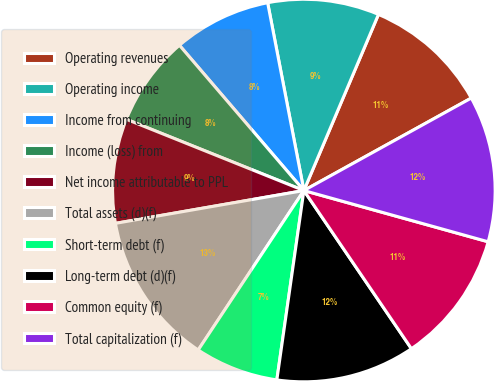Convert chart. <chart><loc_0><loc_0><loc_500><loc_500><pie_chart><fcel>Operating revenues<fcel>Operating income<fcel>Income from continuing<fcel>Income (loss) from<fcel>Net income attributable to PPL<fcel>Total assets (d)(f)<fcel>Short-term debt (f)<fcel>Long-term debt (d)(f)<fcel>Common equity (f)<fcel>Total capitalization (f)<nl><fcel>10.59%<fcel>9.41%<fcel>8.24%<fcel>7.65%<fcel>8.82%<fcel>12.94%<fcel>7.06%<fcel>11.76%<fcel>11.18%<fcel>12.35%<nl></chart> 